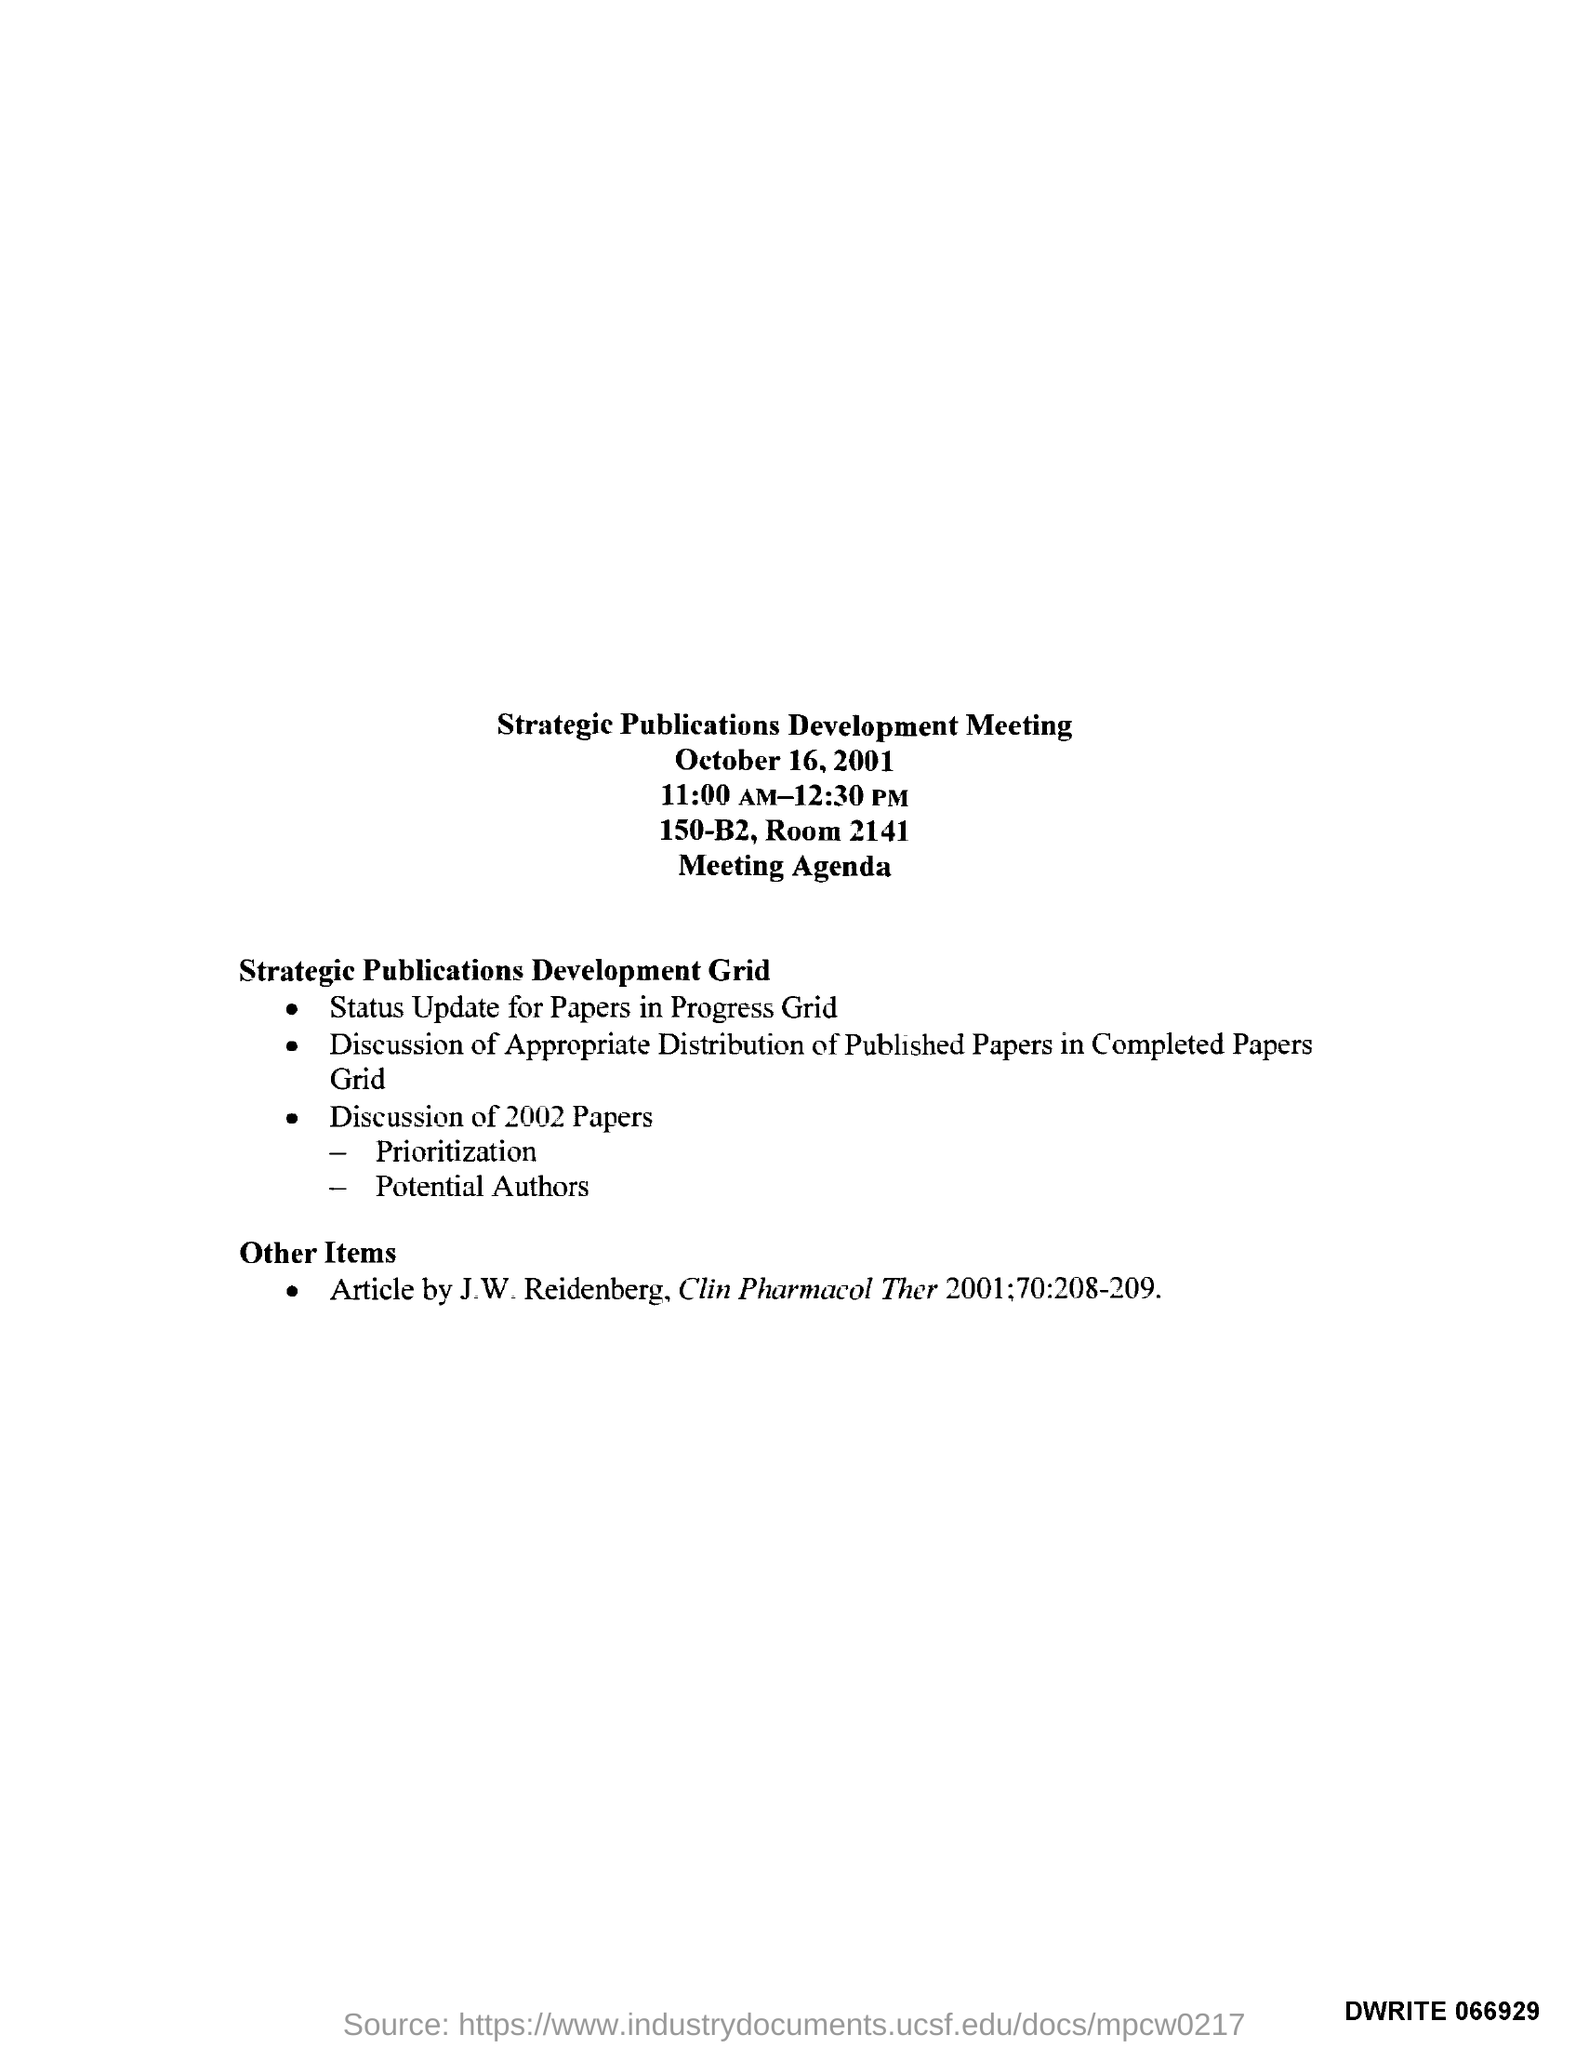What is the title of the document?
Provide a succinct answer. Strategic Publications Development Meeting. What is the room number?
Keep it short and to the point. 2141. 